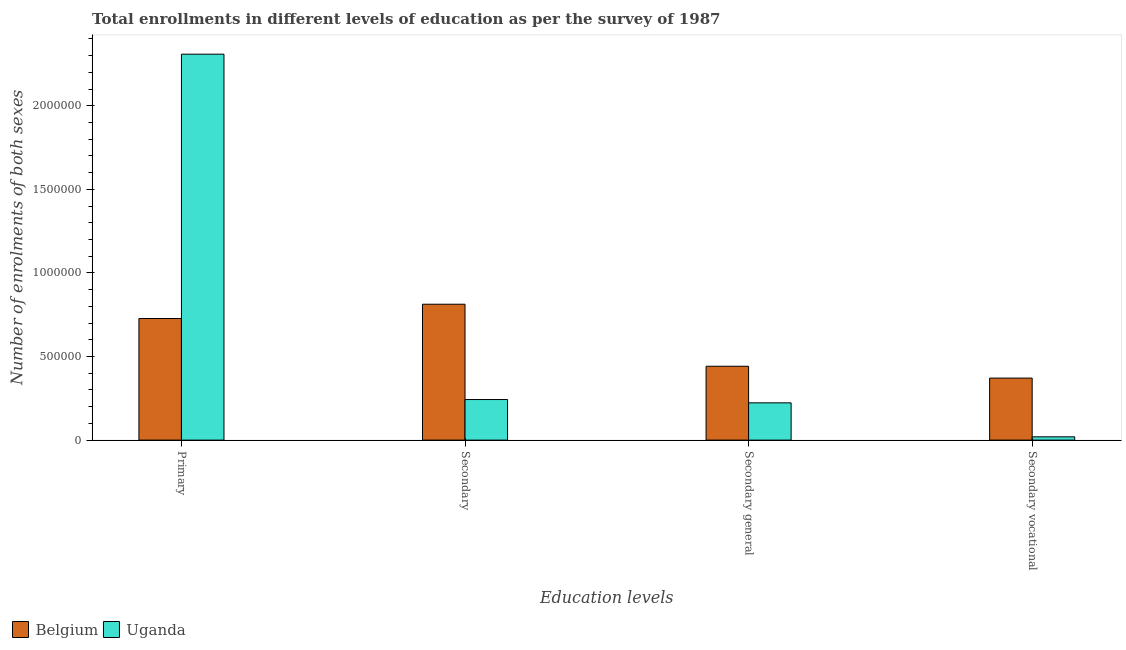How many groups of bars are there?
Your answer should be very brief. 4. How many bars are there on the 2nd tick from the left?
Offer a very short reply. 2. How many bars are there on the 4th tick from the right?
Your answer should be very brief. 2. What is the label of the 1st group of bars from the left?
Your answer should be compact. Primary. What is the number of enrolments in secondary vocational education in Belgium?
Keep it short and to the point. 3.71e+05. Across all countries, what is the maximum number of enrolments in primary education?
Ensure brevity in your answer.  2.31e+06. Across all countries, what is the minimum number of enrolments in secondary education?
Provide a short and direct response. 2.43e+05. In which country was the number of enrolments in secondary general education maximum?
Ensure brevity in your answer.  Belgium. In which country was the number of enrolments in secondary education minimum?
Make the answer very short. Uganda. What is the total number of enrolments in secondary general education in the graph?
Give a very brief answer. 6.65e+05. What is the difference between the number of enrolments in secondary general education in Uganda and that in Belgium?
Offer a terse response. -2.19e+05. What is the difference between the number of enrolments in secondary vocational education in Belgium and the number of enrolments in secondary education in Uganda?
Ensure brevity in your answer.  1.28e+05. What is the average number of enrolments in secondary education per country?
Your response must be concise. 5.28e+05. What is the difference between the number of enrolments in secondary education and number of enrolments in secondary general education in Belgium?
Provide a succinct answer. 3.71e+05. In how many countries, is the number of enrolments in secondary education greater than 2200000 ?
Give a very brief answer. 0. What is the ratio of the number of enrolments in secondary general education in Uganda to that in Belgium?
Ensure brevity in your answer.  0.5. Is the number of enrolments in secondary vocational education in Belgium less than that in Uganda?
Make the answer very short. No. Is the difference between the number of enrolments in secondary general education in Belgium and Uganda greater than the difference between the number of enrolments in primary education in Belgium and Uganda?
Make the answer very short. Yes. What is the difference between the highest and the second highest number of enrolments in secondary education?
Your answer should be very brief. 5.70e+05. What is the difference between the highest and the lowest number of enrolments in secondary general education?
Your answer should be very brief. 2.19e+05. Is the sum of the number of enrolments in secondary general education in Uganda and Belgium greater than the maximum number of enrolments in secondary education across all countries?
Offer a very short reply. No. Is it the case that in every country, the sum of the number of enrolments in secondary education and number of enrolments in primary education is greater than the sum of number of enrolments in secondary vocational education and number of enrolments in secondary general education?
Provide a succinct answer. No. What does the 2nd bar from the left in Secondary vocational represents?
Give a very brief answer. Uganda. Is it the case that in every country, the sum of the number of enrolments in primary education and number of enrolments in secondary education is greater than the number of enrolments in secondary general education?
Your response must be concise. Yes. What is the difference between two consecutive major ticks on the Y-axis?
Your answer should be compact. 5.00e+05. Are the values on the major ticks of Y-axis written in scientific E-notation?
Keep it short and to the point. No. Does the graph contain any zero values?
Provide a short and direct response. No. Does the graph contain grids?
Your response must be concise. No. Where does the legend appear in the graph?
Keep it short and to the point. Bottom left. How many legend labels are there?
Your response must be concise. 2. What is the title of the graph?
Offer a very short reply. Total enrollments in different levels of education as per the survey of 1987. What is the label or title of the X-axis?
Keep it short and to the point. Education levels. What is the label or title of the Y-axis?
Your answer should be compact. Number of enrolments of both sexes. What is the Number of enrolments of both sexes in Belgium in Primary?
Make the answer very short. 7.28e+05. What is the Number of enrolments of both sexes in Uganda in Primary?
Keep it short and to the point. 2.31e+06. What is the Number of enrolments of both sexes in Belgium in Secondary?
Your answer should be very brief. 8.13e+05. What is the Number of enrolments of both sexes in Uganda in Secondary?
Keep it short and to the point. 2.43e+05. What is the Number of enrolments of both sexes of Belgium in Secondary general?
Keep it short and to the point. 4.42e+05. What is the Number of enrolments of both sexes of Uganda in Secondary general?
Provide a short and direct response. 2.23e+05. What is the Number of enrolments of both sexes in Belgium in Secondary vocational?
Your response must be concise. 3.71e+05. What is the Number of enrolments of both sexes in Uganda in Secondary vocational?
Provide a short and direct response. 1.97e+04. Across all Education levels, what is the maximum Number of enrolments of both sexes in Belgium?
Give a very brief answer. 8.13e+05. Across all Education levels, what is the maximum Number of enrolments of both sexes in Uganda?
Your response must be concise. 2.31e+06. Across all Education levels, what is the minimum Number of enrolments of both sexes of Belgium?
Make the answer very short. 3.71e+05. Across all Education levels, what is the minimum Number of enrolments of both sexes in Uganda?
Offer a very short reply. 1.97e+04. What is the total Number of enrolments of both sexes of Belgium in the graph?
Ensure brevity in your answer.  2.35e+06. What is the total Number of enrolments of both sexes of Uganda in the graph?
Make the answer very short. 2.79e+06. What is the difference between the Number of enrolments of both sexes in Belgium in Primary and that in Secondary?
Offer a very short reply. -8.53e+04. What is the difference between the Number of enrolments of both sexes in Uganda in Primary and that in Secondary?
Provide a succinct answer. 2.07e+06. What is the difference between the Number of enrolments of both sexes in Belgium in Primary and that in Secondary general?
Your answer should be compact. 2.86e+05. What is the difference between the Number of enrolments of both sexes of Uganda in Primary and that in Secondary general?
Offer a very short reply. 2.09e+06. What is the difference between the Number of enrolments of both sexes of Belgium in Primary and that in Secondary vocational?
Keep it short and to the point. 3.57e+05. What is the difference between the Number of enrolments of both sexes in Uganda in Primary and that in Secondary vocational?
Your response must be concise. 2.29e+06. What is the difference between the Number of enrolments of both sexes of Belgium in Secondary and that in Secondary general?
Make the answer very short. 3.71e+05. What is the difference between the Number of enrolments of both sexes in Uganda in Secondary and that in Secondary general?
Offer a very short reply. 1.97e+04. What is the difference between the Number of enrolments of both sexes of Belgium in Secondary and that in Secondary vocational?
Offer a very short reply. 4.42e+05. What is the difference between the Number of enrolments of both sexes of Uganda in Secondary and that in Secondary vocational?
Offer a very short reply. 2.23e+05. What is the difference between the Number of enrolments of both sexes in Belgium in Secondary general and that in Secondary vocational?
Ensure brevity in your answer.  7.08e+04. What is the difference between the Number of enrolments of both sexes of Uganda in Secondary general and that in Secondary vocational?
Make the answer very short. 2.03e+05. What is the difference between the Number of enrolments of both sexes in Belgium in Primary and the Number of enrolments of both sexes in Uganda in Secondary?
Make the answer very short. 4.85e+05. What is the difference between the Number of enrolments of both sexes of Belgium in Primary and the Number of enrolments of both sexes of Uganda in Secondary general?
Keep it short and to the point. 5.05e+05. What is the difference between the Number of enrolments of both sexes in Belgium in Primary and the Number of enrolments of both sexes in Uganda in Secondary vocational?
Offer a very short reply. 7.08e+05. What is the difference between the Number of enrolments of both sexes in Belgium in Secondary and the Number of enrolments of both sexes in Uganda in Secondary general?
Keep it short and to the point. 5.90e+05. What is the difference between the Number of enrolments of both sexes in Belgium in Secondary and the Number of enrolments of both sexes in Uganda in Secondary vocational?
Give a very brief answer. 7.93e+05. What is the difference between the Number of enrolments of both sexes in Belgium in Secondary general and the Number of enrolments of both sexes in Uganda in Secondary vocational?
Your answer should be very brief. 4.22e+05. What is the average Number of enrolments of both sexes of Belgium per Education levels?
Provide a short and direct response. 5.88e+05. What is the average Number of enrolments of both sexes in Uganda per Education levels?
Give a very brief answer. 6.99e+05. What is the difference between the Number of enrolments of both sexes of Belgium and Number of enrolments of both sexes of Uganda in Primary?
Your answer should be compact. -1.58e+06. What is the difference between the Number of enrolments of both sexes of Belgium and Number of enrolments of both sexes of Uganda in Secondary?
Provide a succinct answer. 5.70e+05. What is the difference between the Number of enrolments of both sexes in Belgium and Number of enrolments of both sexes in Uganda in Secondary general?
Provide a succinct answer. 2.19e+05. What is the difference between the Number of enrolments of both sexes in Belgium and Number of enrolments of both sexes in Uganda in Secondary vocational?
Your answer should be very brief. 3.51e+05. What is the ratio of the Number of enrolments of both sexes in Belgium in Primary to that in Secondary?
Make the answer very short. 0.9. What is the ratio of the Number of enrolments of both sexes in Uganda in Primary to that in Secondary?
Keep it short and to the point. 9.51. What is the ratio of the Number of enrolments of both sexes of Belgium in Primary to that in Secondary general?
Provide a succinct answer. 1.65. What is the ratio of the Number of enrolments of both sexes of Uganda in Primary to that in Secondary general?
Ensure brevity in your answer.  10.35. What is the ratio of the Number of enrolments of both sexes of Belgium in Primary to that in Secondary vocational?
Keep it short and to the point. 1.96. What is the ratio of the Number of enrolments of both sexes of Uganda in Primary to that in Secondary vocational?
Provide a succinct answer. 117.05. What is the ratio of the Number of enrolments of both sexes in Belgium in Secondary to that in Secondary general?
Give a very brief answer. 1.84. What is the ratio of the Number of enrolments of both sexes of Uganda in Secondary to that in Secondary general?
Offer a terse response. 1.09. What is the ratio of the Number of enrolments of both sexes in Belgium in Secondary to that in Secondary vocational?
Provide a short and direct response. 2.19. What is the ratio of the Number of enrolments of both sexes of Uganda in Secondary to that in Secondary vocational?
Your answer should be compact. 12.3. What is the ratio of the Number of enrolments of both sexes of Belgium in Secondary general to that in Secondary vocational?
Your answer should be very brief. 1.19. What is the ratio of the Number of enrolments of both sexes in Uganda in Secondary general to that in Secondary vocational?
Your answer should be very brief. 11.3. What is the difference between the highest and the second highest Number of enrolments of both sexes of Belgium?
Offer a very short reply. 8.53e+04. What is the difference between the highest and the second highest Number of enrolments of both sexes in Uganda?
Your response must be concise. 2.07e+06. What is the difference between the highest and the lowest Number of enrolments of both sexes in Belgium?
Give a very brief answer. 4.42e+05. What is the difference between the highest and the lowest Number of enrolments of both sexes in Uganda?
Keep it short and to the point. 2.29e+06. 